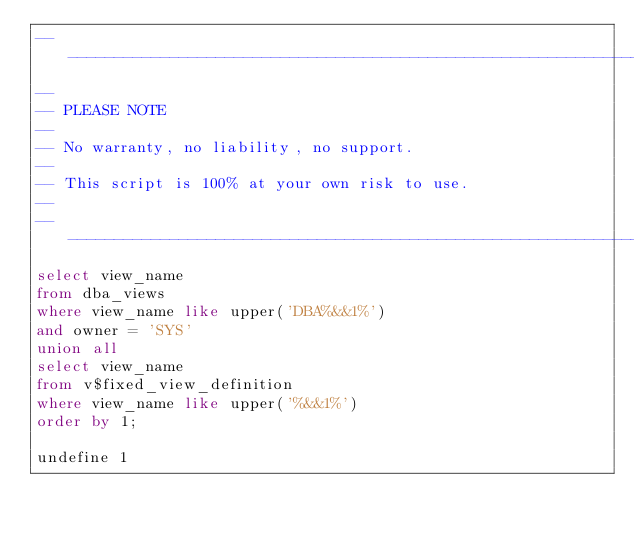<code> <loc_0><loc_0><loc_500><loc_500><_SQL_>-------------------------------------------------------------------------------
--
-- PLEASE NOTE
-- 
-- No warranty, no liability, no support.
--
-- This script is 100% at your own risk to use.
--
-------------------------------------------------------------------------------
select view_name
from dba_views
where view_name like upper('DBA%&&1%')
and owner = 'SYS'
union all
select view_name
from v$fixed_view_definition
where view_name like upper('%&&1%')
order by 1;

undefine 1
</code> 